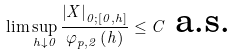Convert formula to latex. <formula><loc_0><loc_0><loc_500><loc_500>\lim \sup _ { h \downarrow 0 } \frac { \left | X \right | _ { 0 ; \left [ 0 , h \right ] } } { \varphi _ { p , 2 } \left ( h \right ) } \leq C \text { a.s.}</formula> 